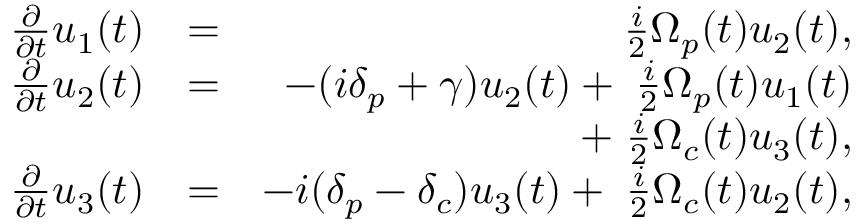Convert formula to latex. <formula><loc_0><loc_0><loc_500><loc_500>\begin{array} { r l r } { \frac { \partial } { \partial t } { u } _ { 1 } ( t ) } & { = } & { \, \frac { i } { 2 } { \Omega } _ { p } ( t ) u _ { 2 } ( t ) , } \\ { \frac { \partial } { \partial t } { u } _ { 2 } ( t ) } & { = } & { - ( i \delta _ { p } + \gamma ) u _ { 2 } ( t ) + \, \frac { i } { 2 } { \Omega } _ { p } ( t ) u _ { 1 } ( t ) } \\ & { + \, \frac { i } { 2 } { \Omega } _ { c } ( t ) u _ { 3 } ( t ) , } \\ { \frac { \partial } { \partial t } { u } _ { 3 } ( t ) } & { = } & { - i ( \delta _ { p } - \delta _ { c } ) u _ { 3 } ( t ) + \, \frac { i } { 2 } { \Omega } _ { c } ( t ) u _ { 2 } ( t ) , } \end{array}</formula> 